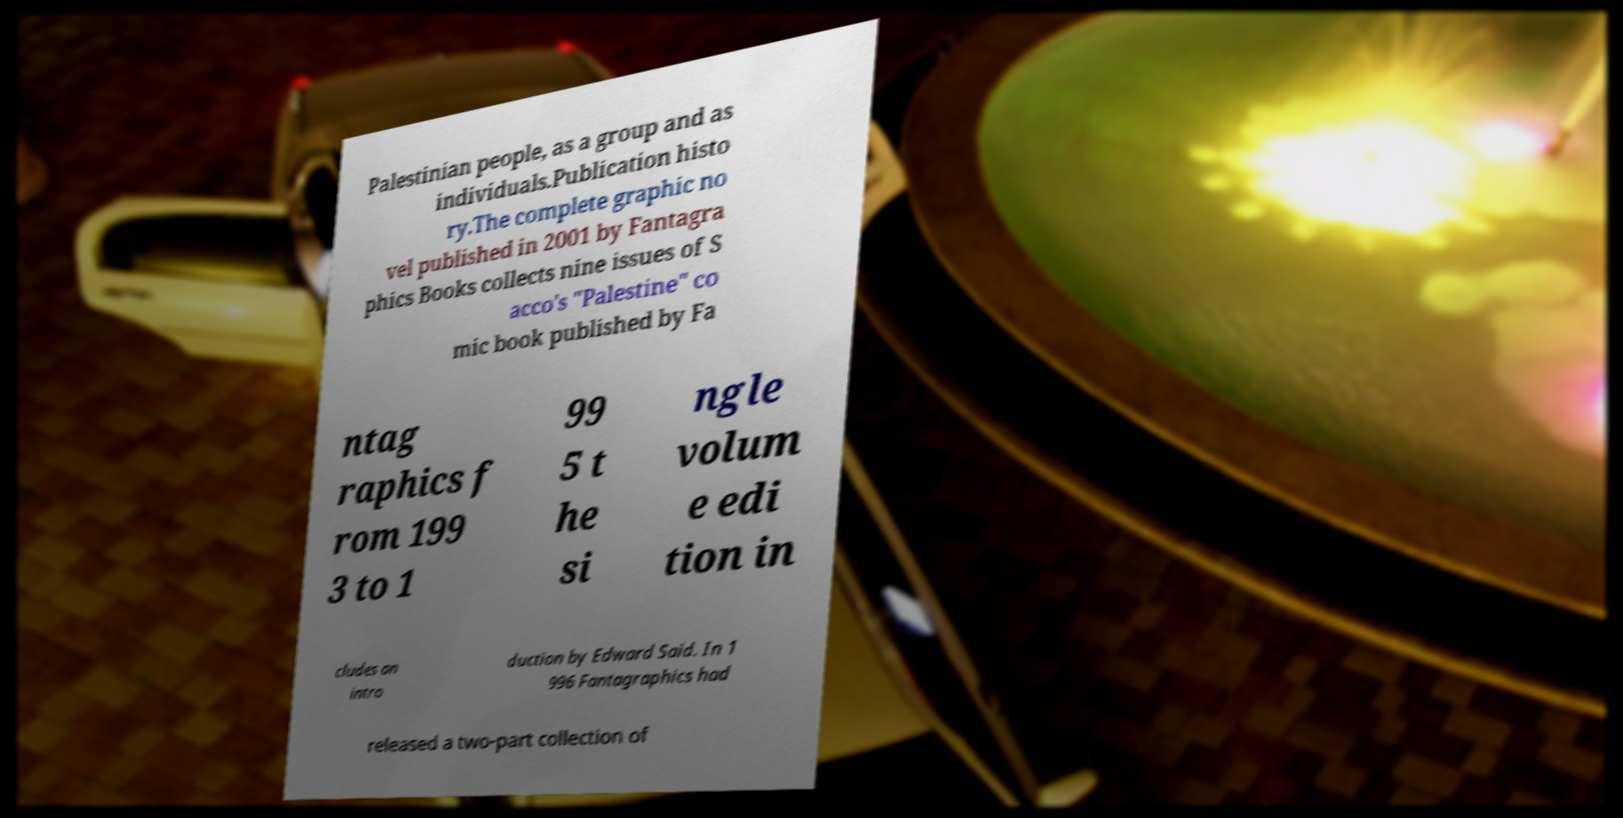There's text embedded in this image that I need extracted. Can you transcribe it verbatim? Palestinian people, as a group and as individuals.Publication histo ry.The complete graphic no vel published in 2001 by Fantagra phics Books collects nine issues of S acco's "Palestine" co mic book published by Fa ntag raphics f rom 199 3 to 1 99 5 t he si ngle volum e edi tion in cludes an intro duction by Edward Said. In 1 996 Fantagraphics had released a two-part collection of 